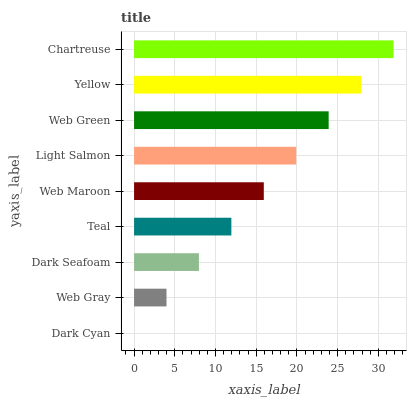Is Dark Cyan the minimum?
Answer yes or no. Yes. Is Chartreuse the maximum?
Answer yes or no. Yes. Is Web Gray the minimum?
Answer yes or no. No. Is Web Gray the maximum?
Answer yes or no. No. Is Web Gray greater than Dark Cyan?
Answer yes or no. Yes. Is Dark Cyan less than Web Gray?
Answer yes or no. Yes. Is Dark Cyan greater than Web Gray?
Answer yes or no. No. Is Web Gray less than Dark Cyan?
Answer yes or no. No. Is Web Maroon the high median?
Answer yes or no. Yes. Is Web Maroon the low median?
Answer yes or no. Yes. Is Chartreuse the high median?
Answer yes or no. No. Is Dark Cyan the low median?
Answer yes or no. No. 